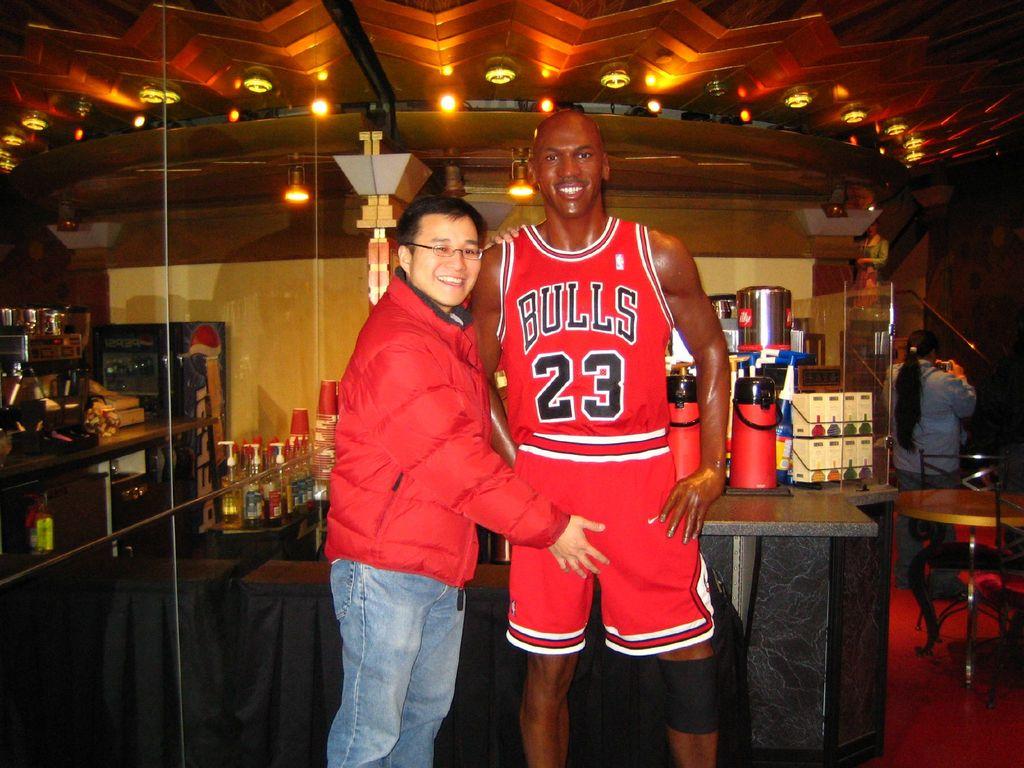What team is that jersey for?
Your response must be concise. Bulls. What number is on his jersey?
Offer a terse response. 23. 